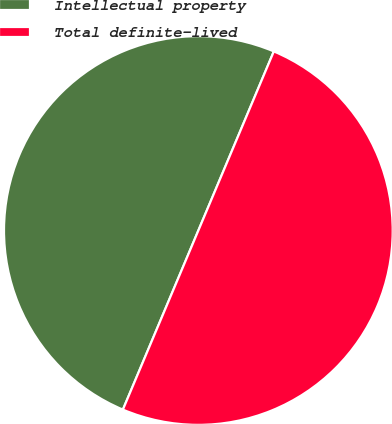Convert chart. <chart><loc_0><loc_0><loc_500><loc_500><pie_chart><fcel>Intellectual property<fcel>Total definite-lived<nl><fcel>50.0%<fcel>50.0%<nl></chart> 